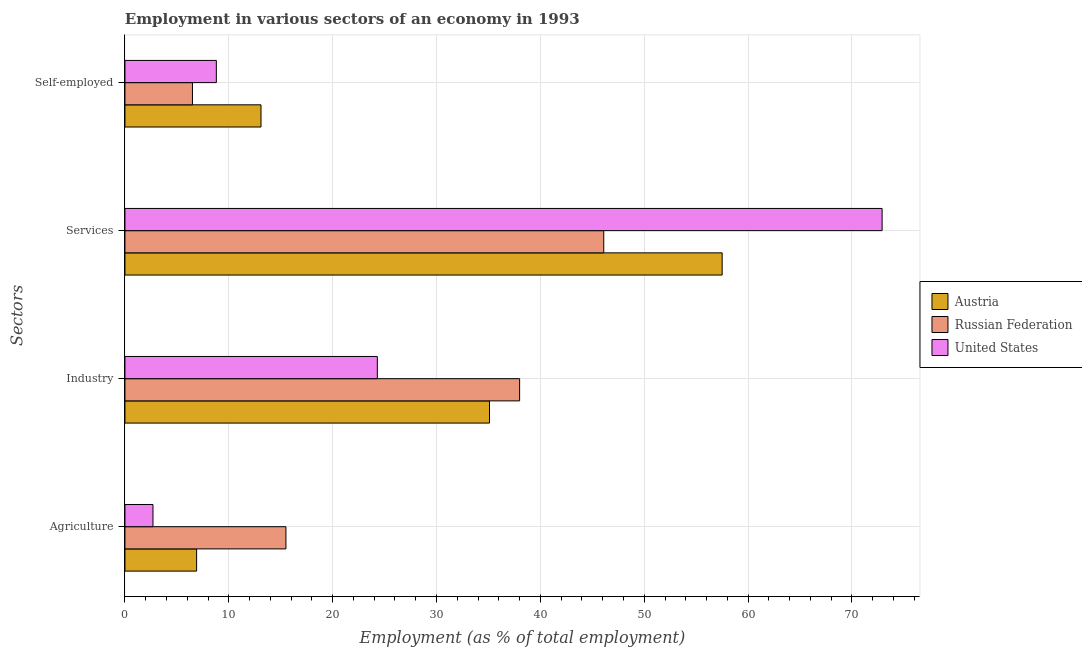How many groups of bars are there?
Your answer should be compact. 4. How many bars are there on the 4th tick from the bottom?
Offer a very short reply. 3. What is the label of the 2nd group of bars from the top?
Make the answer very short. Services. What is the percentage of workers in industry in Austria?
Provide a succinct answer. 35.1. Across all countries, what is the minimum percentage of workers in agriculture?
Provide a succinct answer. 2.7. In which country was the percentage of workers in agriculture maximum?
Give a very brief answer. Russian Federation. What is the total percentage of workers in agriculture in the graph?
Provide a succinct answer. 25.1. What is the difference between the percentage of workers in services in Austria and that in Russian Federation?
Your response must be concise. 11.4. What is the difference between the percentage of workers in services in Russian Federation and the percentage of self employed workers in United States?
Your response must be concise. 37.3. What is the average percentage of workers in services per country?
Offer a very short reply. 58.83. What is the difference between the percentage of workers in services and percentage of workers in agriculture in United States?
Ensure brevity in your answer.  70.2. What is the ratio of the percentage of workers in industry in United States to that in Austria?
Your response must be concise. 0.69. What is the difference between the highest and the second highest percentage of self employed workers?
Make the answer very short. 4.3. What is the difference between the highest and the lowest percentage of workers in agriculture?
Your answer should be very brief. 12.8. What does the 2nd bar from the top in Industry represents?
Give a very brief answer. Russian Federation. What does the 3rd bar from the bottom in Self-employed represents?
Your response must be concise. United States. How many bars are there?
Give a very brief answer. 12. Are all the bars in the graph horizontal?
Provide a succinct answer. Yes. What is the difference between two consecutive major ticks on the X-axis?
Your answer should be compact. 10. Are the values on the major ticks of X-axis written in scientific E-notation?
Provide a short and direct response. No. Does the graph contain grids?
Provide a short and direct response. Yes. How many legend labels are there?
Your answer should be very brief. 3. How are the legend labels stacked?
Provide a short and direct response. Vertical. What is the title of the graph?
Keep it short and to the point. Employment in various sectors of an economy in 1993. Does "Central Europe" appear as one of the legend labels in the graph?
Provide a succinct answer. No. What is the label or title of the X-axis?
Your answer should be very brief. Employment (as % of total employment). What is the label or title of the Y-axis?
Your response must be concise. Sectors. What is the Employment (as % of total employment) in Austria in Agriculture?
Your answer should be very brief. 6.9. What is the Employment (as % of total employment) in United States in Agriculture?
Provide a short and direct response. 2.7. What is the Employment (as % of total employment) of Austria in Industry?
Ensure brevity in your answer.  35.1. What is the Employment (as % of total employment) of Russian Federation in Industry?
Provide a succinct answer. 38. What is the Employment (as % of total employment) of United States in Industry?
Your answer should be compact. 24.3. What is the Employment (as % of total employment) in Austria in Services?
Provide a succinct answer. 57.5. What is the Employment (as % of total employment) of Russian Federation in Services?
Your response must be concise. 46.1. What is the Employment (as % of total employment) in United States in Services?
Ensure brevity in your answer.  72.9. What is the Employment (as % of total employment) in Austria in Self-employed?
Offer a terse response. 13.1. What is the Employment (as % of total employment) in Russian Federation in Self-employed?
Provide a succinct answer. 6.5. What is the Employment (as % of total employment) in United States in Self-employed?
Your answer should be compact. 8.8. Across all Sectors, what is the maximum Employment (as % of total employment) of Austria?
Keep it short and to the point. 57.5. Across all Sectors, what is the maximum Employment (as % of total employment) in Russian Federation?
Keep it short and to the point. 46.1. Across all Sectors, what is the maximum Employment (as % of total employment) in United States?
Provide a short and direct response. 72.9. Across all Sectors, what is the minimum Employment (as % of total employment) in Austria?
Give a very brief answer. 6.9. Across all Sectors, what is the minimum Employment (as % of total employment) of United States?
Provide a succinct answer. 2.7. What is the total Employment (as % of total employment) in Austria in the graph?
Offer a very short reply. 112.6. What is the total Employment (as % of total employment) in Russian Federation in the graph?
Keep it short and to the point. 106.1. What is the total Employment (as % of total employment) in United States in the graph?
Make the answer very short. 108.7. What is the difference between the Employment (as % of total employment) in Austria in Agriculture and that in Industry?
Your answer should be compact. -28.2. What is the difference between the Employment (as % of total employment) of Russian Federation in Agriculture and that in Industry?
Offer a very short reply. -22.5. What is the difference between the Employment (as % of total employment) of United States in Agriculture and that in Industry?
Give a very brief answer. -21.6. What is the difference between the Employment (as % of total employment) in Austria in Agriculture and that in Services?
Offer a terse response. -50.6. What is the difference between the Employment (as % of total employment) in Russian Federation in Agriculture and that in Services?
Your response must be concise. -30.6. What is the difference between the Employment (as % of total employment) in United States in Agriculture and that in Services?
Provide a short and direct response. -70.2. What is the difference between the Employment (as % of total employment) in Austria in Agriculture and that in Self-employed?
Your response must be concise. -6.2. What is the difference between the Employment (as % of total employment) in Austria in Industry and that in Services?
Your response must be concise. -22.4. What is the difference between the Employment (as % of total employment) in United States in Industry and that in Services?
Your response must be concise. -48.6. What is the difference between the Employment (as % of total employment) of Russian Federation in Industry and that in Self-employed?
Your response must be concise. 31.5. What is the difference between the Employment (as % of total employment) in United States in Industry and that in Self-employed?
Provide a short and direct response. 15.5. What is the difference between the Employment (as % of total employment) in Austria in Services and that in Self-employed?
Give a very brief answer. 44.4. What is the difference between the Employment (as % of total employment) in Russian Federation in Services and that in Self-employed?
Your answer should be compact. 39.6. What is the difference between the Employment (as % of total employment) in United States in Services and that in Self-employed?
Offer a very short reply. 64.1. What is the difference between the Employment (as % of total employment) of Austria in Agriculture and the Employment (as % of total employment) of Russian Federation in Industry?
Ensure brevity in your answer.  -31.1. What is the difference between the Employment (as % of total employment) in Austria in Agriculture and the Employment (as % of total employment) in United States in Industry?
Give a very brief answer. -17.4. What is the difference between the Employment (as % of total employment) of Russian Federation in Agriculture and the Employment (as % of total employment) of United States in Industry?
Your answer should be very brief. -8.8. What is the difference between the Employment (as % of total employment) of Austria in Agriculture and the Employment (as % of total employment) of Russian Federation in Services?
Provide a succinct answer. -39.2. What is the difference between the Employment (as % of total employment) in Austria in Agriculture and the Employment (as % of total employment) in United States in Services?
Keep it short and to the point. -66. What is the difference between the Employment (as % of total employment) in Russian Federation in Agriculture and the Employment (as % of total employment) in United States in Services?
Give a very brief answer. -57.4. What is the difference between the Employment (as % of total employment) in Austria in Agriculture and the Employment (as % of total employment) in Russian Federation in Self-employed?
Ensure brevity in your answer.  0.4. What is the difference between the Employment (as % of total employment) in Austria in Agriculture and the Employment (as % of total employment) in United States in Self-employed?
Ensure brevity in your answer.  -1.9. What is the difference between the Employment (as % of total employment) of Russian Federation in Agriculture and the Employment (as % of total employment) of United States in Self-employed?
Your answer should be compact. 6.7. What is the difference between the Employment (as % of total employment) of Austria in Industry and the Employment (as % of total employment) of United States in Services?
Offer a very short reply. -37.8. What is the difference between the Employment (as % of total employment) in Russian Federation in Industry and the Employment (as % of total employment) in United States in Services?
Offer a terse response. -34.9. What is the difference between the Employment (as % of total employment) in Austria in Industry and the Employment (as % of total employment) in Russian Federation in Self-employed?
Your answer should be compact. 28.6. What is the difference between the Employment (as % of total employment) in Austria in Industry and the Employment (as % of total employment) in United States in Self-employed?
Provide a short and direct response. 26.3. What is the difference between the Employment (as % of total employment) of Russian Federation in Industry and the Employment (as % of total employment) of United States in Self-employed?
Ensure brevity in your answer.  29.2. What is the difference between the Employment (as % of total employment) in Austria in Services and the Employment (as % of total employment) in United States in Self-employed?
Your response must be concise. 48.7. What is the difference between the Employment (as % of total employment) of Russian Federation in Services and the Employment (as % of total employment) of United States in Self-employed?
Offer a very short reply. 37.3. What is the average Employment (as % of total employment) of Austria per Sectors?
Keep it short and to the point. 28.15. What is the average Employment (as % of total employment) in Russian Federation per Sectors?
Offer a very short reply. 26.52. What is the average Employment (as % of total employment) of United States per Sectors?
Your answer should be compact. 27.18. What is the difference between the Employment (as % of total employment) of Austria and Employment (as % of total employment) of United States in Agriculture?
Offer a terse response. 4.2. What is the difference between the Employment (as % of total employment) in Russian Federation and Employment (as % of total employment) in United States in Agriculture?
Offer a very short reply. 12.8. What is the difference between the Employment (as % of total employment) in Russian Federation and Employment (as % of total employment) in United States in Industry?
Your answer should be compact. 13.7. What is the difference between the Employment (as % of total employment) in Austria and Employment (as % of total employment) in United States in Services?
Provide a succinct answer. -15.4. What is the difference between the Employment (as % of total employment) in Russian Federation and Employment (as % of total employment) in United States in Services?
Make the answer very short. -26.8. What is the difference between the Employment (as % of total employment) in Austria and Employment (as % of total employment) in Russian Federation in Self-employed?
Ensure brevity in your answer.  6.6. What is the difference between the Employment (as % of total employment) of Russian Federation and Employment (as % of total employment) of United States in Self-employed?
Provide a short and direct response. -2.3. What is the ratio of the Employment (as % of total employment) of Austria in Agriculture to that in Industry?
Keep it short and to the point. 0.2. What is the ratio of the Employment (as % of total employment) of Russian Federation in Agriculture to that in Industry?
Give a very brief answer. 0.41. What is the ratio of the Employment (as % of total employment) in United States in Agriculture to that in Industry?
Ensure brevity in your answer.  0.11. What is the ratio of the Employment (as % of total employment) in Austria in Agriculture to that in Services?
Offer a terse response. 0.12. What is the ratio of the Employment (as % of total employment) of Russian Federation in Agriculture to that in Services?
Give a very brief answer. 0.34. What is the ratio of the Employment (as % of total employment) of United States in Agriculture to that in Services?
Offer a terse response. 0.04. What is the ratio of the Employment (as % of total employment) in Austria in Agriculture to that in Self-employed?
Make the answer very short. 0.53. What is the ratio of the Employment (as % of total employment) in Russian Federation in Agriculture to that in Self-employed?
Make the answer very short. 2.38. What is the ratio of the Employment (as % of total employment) in United States in Agriculture to that in Self-employed?
Your response must be concise. 0.31. What is the ratio of the Employment (as % of total employment) in Austria in Industry to that in Services?
Offer a very short reply. 0.61. What is the ratio of the Employment (as % of total employment) of Russian Federation in Industry to that in Services?
Keep it short and to the point. 0.82. What is the ratio of the Employment (as % of total employment) in United States in Industry to that in Services?
Provide a succinct answer. 0.33. What is the ratio of the Employment (as % of total employment) of Austria in Industry to that in Self-employed?
Ensure brevity in your answer.  2.68. What is the ratio of the Employment (as % of total employment) of Russian Federation in Industry to that in Self-employed?
Make the answer very short. 5.85. What is the ratio of the Employment (as % of total employment) in United States in Industry to that in Self-employed?
Ensure brevity in your answer.  2.76. What is the ratio of the Employment (as % of total employment) in Austria in Services to that in Self-employed?
Provide a short and direct response. 4.39. What is the ratio of the Employment (as % of total employment) in Russian Federation in Services to that in Self-employed?
Offer a very short reply. 7.09. What is the ratio of the Employment (as % of total employment) in United States in Services to that in Self-employed?
Make the answer very short. 8.28. What is the difference between the highest and the second highest Employment (as % of total employment) of Austria?
Your answer should be compact. 22.4. What is the difference between the highest and the second highest Employment (as % of total employment) in United States?
Your answer should be compact. 48.6. What is the difference between the highest and the lowest Employment (as % of total employment) of Austria?
Your answer should be compact. 50.6. What is the difference between the highest and the lowest Employment (as % of total employment) of Russian Federation?
Offer a very short reply. 39.6. What is the difference between the highest and the lowest Employment (as % of total employment) of United States?
Give a very brief answer. 70.2. 